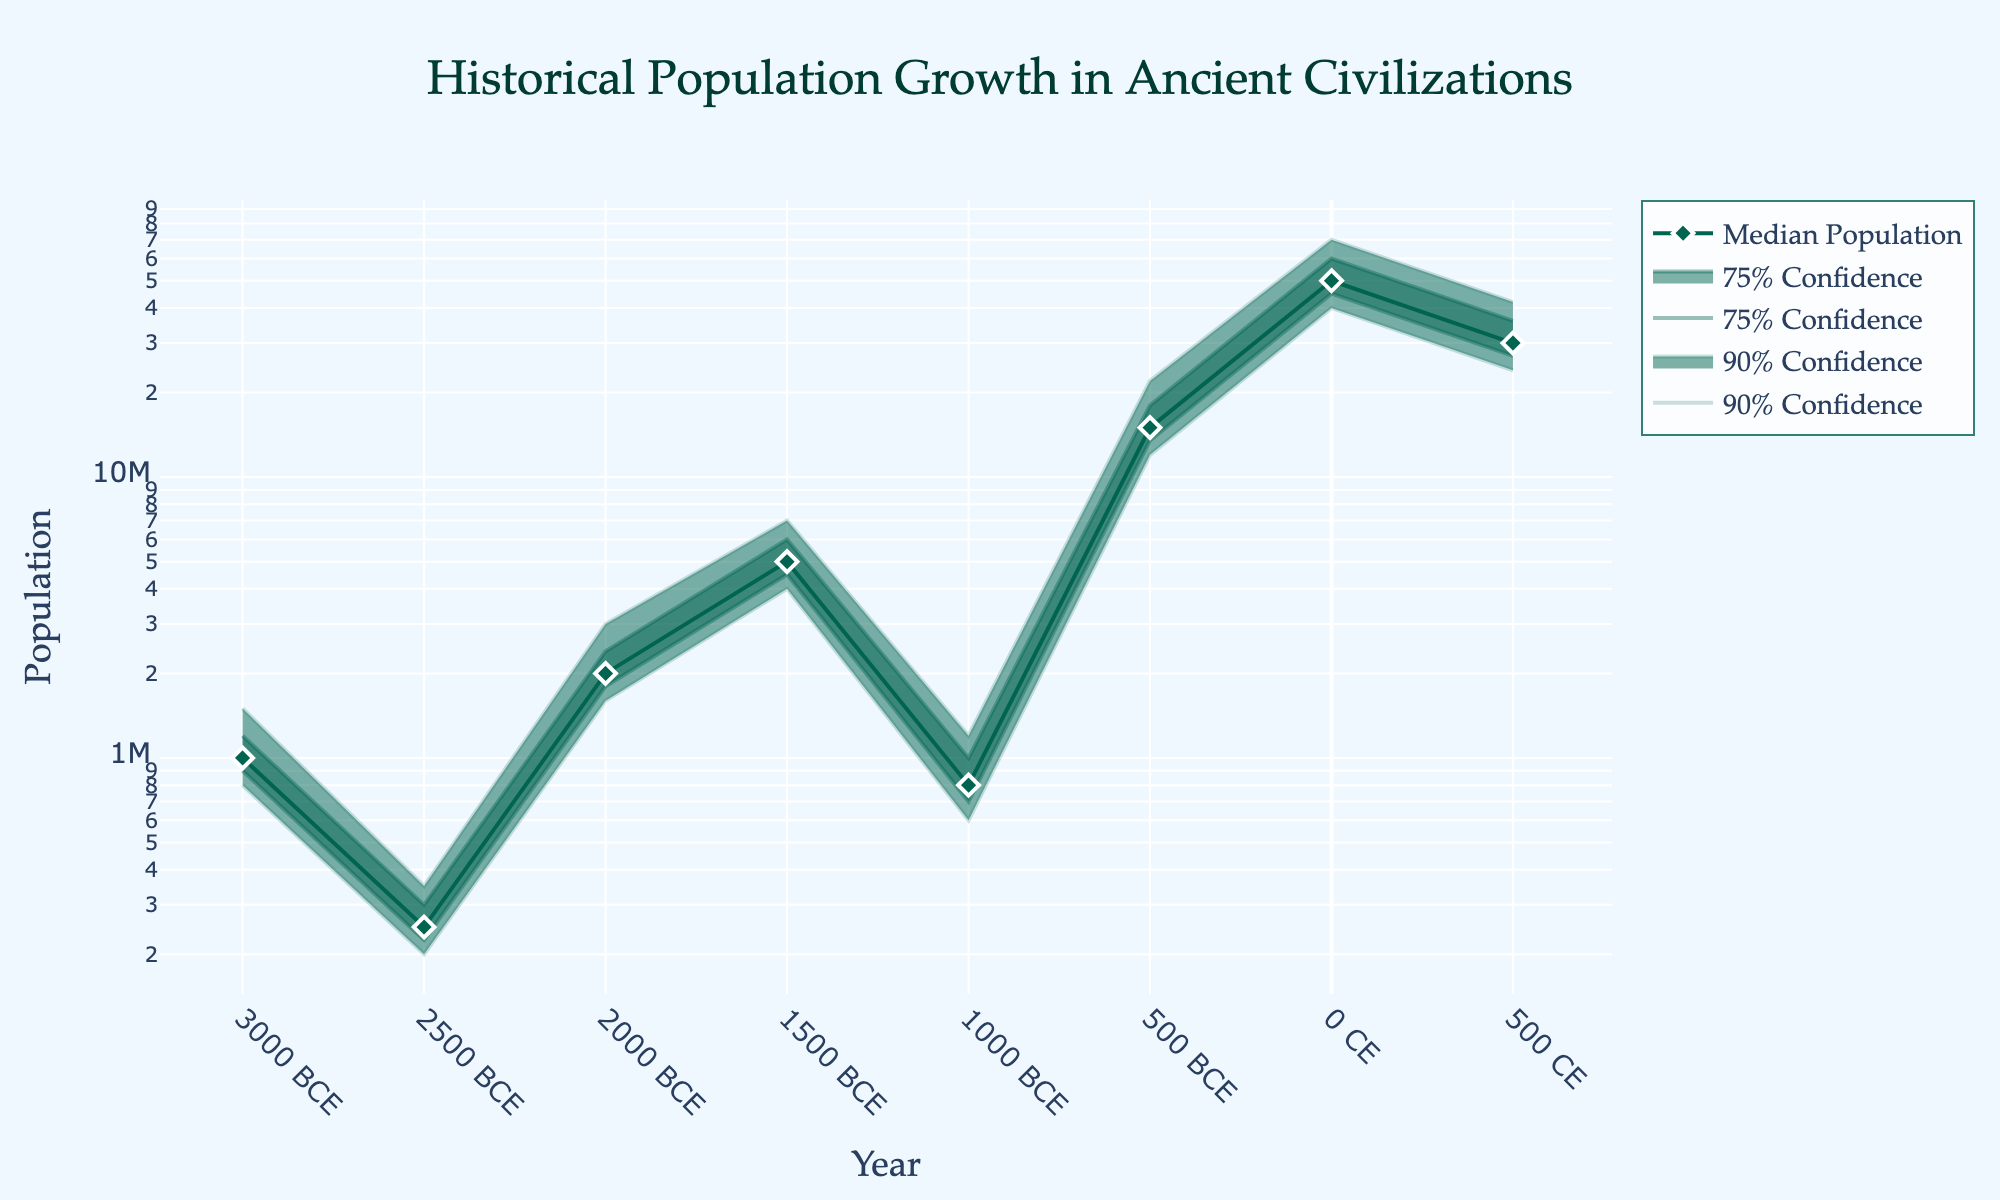What is the title of the figure? The title can be found at the top of the figure and usually describes the main content or subject of the figure. In this case, it is clearly labeled at the top.
Answer: Historical Population Growth in Ancient Civilizations What does the x-axis represent? The x-axis typically represents the independent variable in a chart or graph. Here, it is labeled and represents the years, marked with specific dates in either BCE or CE.
Answer: Years What does the y-axis represent? The y-axis typically represents the dependent variable in a chart or graph. Here, it is labeled as "Population" and uses a logarithmic scale to show the population sizes of various civilizations.
Answer: Population Which civilization had the highest median population around year 0? The median populations are marked with diamond symbols on the plot, and each civilization is annotated. By locating the year 0 on the x-axis and checking the corresponding annotation, we see that the Roman Empire had the highest median population.
Answer: Roman Empire What is the approximate median population of the Byzantine Empire around year 500? Locate the diamond symbol for the year 500 on the x-axis and check its y-axis value. The annotation for the Byzantine Empire helps to identify this and approximates the median population at that point.
Answer: 30,000,000 Between the Shang Dynasty China and the Mycenaean Greece, which one has a higher median population around year -1500? Locate the year -1500 on the x-axis, and find the corresponding median population diamond symbols for both civilizations. The annotation helps in identifying them: the Shang Dynasty China has a higher median population.
Answer: Shang Dynasty China What can you say about the range of population uncertainty for the Achaemenid Persia around year -500? The range of population uncertainty is defined by the area between the lower and upper confidence intervals. Locate year -500 on the x-axis, and look at the corresponding shaded areas. The distance between the lower 10% (12,000,000) and upper 90% (22,000,000) boundaries shows a wide range of uncertainty.
Answer: Wide range (12,000,000 to 22,000,000) Which civilization shows the largest growth in median population over the given time range? Examine the diamond symbols connected by lines which represent the median populations over time. The Roman Empire, from its relative position, shows the largest growth reaching 50,000,000 around year 0.
Answer: Roman Empire How does the lower 25% confidence interval for the Indus Valley around year -2000 compare to the lower 10% confidence interval for Ancient Egypt around year -3000? Locate both civilizations and respective years on the x-axis. Compare the lower 25% for Indus Valley (1,800,000) with the lower 10% for Ancient Egypt (800,000). The lower 25% for Indus Valley is significantly higher.
Answer: Indus Valley's lower 25% is higher (1,800,000 vs. 800,000) From year -1000 to 0, which civilization had the most significant population decrease in median values? Follow the diamond symbols from year -1000 to 0, noting changes in their relative positions. Observing these changes, Mycenaean Greece shows a notable decrease in median population.
Answer: Mycenaean Greece 